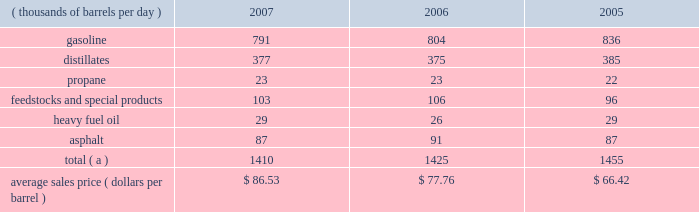Marketing we are a supplier of gasoline and distillates to resellers and consumers within our market area in the midwest , upper great plains , gulf coast and southeastern regions of the united states .
In 2007 , our refined products sales volumes totaled 21.6 billion gallons , or 1.410 mmbpd .
The average sales price of our refined products in aggregate was $ 86.53 per barrel for 2007 .
The table sets forth our refined products sales by product group and our average sales price for each of the last three years .
Refined product sales ( thousands of barrels per day ) 2007 2006 2005 .
Total ( a ) 1410 1425 1455 average sales price ( dollars per barrel ) $ 86.53 $ 77.76 $ 66.42 ( a ) includes matching buy/sell volumes of 24 mbpd and 77 mbpd in 2006 and 2005 .
On april 1 , 2006 , we changed our accounting for matching buy/sell arrangements as a result of a new accounting standard .
This change resulted in lower refined products sales volumes for 2007 and the remainder of 2006 than would have been reported under our previous accounting practices .
See note 2 to the consolidated financial statements .
The wholesale distribution of petroleum products to private brand marketers and to large commercial and industrial consumers and sales in the spot market accounted for 69 percent of our refined products sales volumes in 2007 .
We sold 49 percent of our gasoline volumes and 89 percent of our distillates volumes on a wholesale or spot market basis .
Half of our propane is sold into the home heating market , with the balance being purchased by industrial consumers .
Propylene , cumene , aromatics , aliphatics and sulfur are domestically marketed to customers in the chemical industry .
Base lube oils , maleic anhydride , slack wax , extract and pitch are sold throughout the united states and canada , with pitch products also being exported worldwide .
We market asphalt through owned and leased terminals throughout the midwest , upper great plains , gulf coast and southeastern regions of the united states .
Our customer base includes approximately 750 asphalt-paving contractors , government entities ( states , counties , cities and townships ) and asphalt roofing shingle manufacturers .
We have blended ethanol with gasoline for over 15 years and increased our blending program in 2007 , in part due to renewable fuel mandates .
We blended 41 mbpd of ethanol into gasoline in 2007 and 35 mbpd in both 2006 and 2005 .
The future expansion or contraction of our ethanol blending program will be driven by the economics of the ethanol supply and changes in government regulations .
We sell reformulated gasoline in parts of our marketing territory , primarily chicago , illinois ; louisville , kentucky ; northern kentucky ; milwaukee , wisconsin and hartford , illinois , and we sell low-vapor-pressure gasoline in nine states .
We also sell biodiesel in minnesota , illinois and kentucky .
As of december 31 , 2007 , we supplied petroleum products to about 4400 marathon branded-retail outlets located primarily in ohio , michigan , indiana , kentucky and illinois .
Branded retail outlets are also located in georgia , florida , minnesota , wisconsin , north carolina , tennessee , west virginia , virginia , south carolina , alabama , pennsylvania , and texas .
Sales to marathon-brand jobbers and dealers accounted for 16 percent of our refined product sales volumes in 2007 .
Speedway superamerica llc ( 201cssa 201d ) , our wholly-owned subsidiary , sells gasoline and diesel fuel primarily through retail outlets that we operate .
Sales of refined products through these ssa retail outlets accounted for 15 percent of our refined products sales volumes in 2007 .
As of december 31 , 2007 , ssa had 1636 retail outlets in nine states that sold petroleum products and convenience store merchandise and services , primarily under the brand names 201cspeedway 201d and 201csuperamerica . 201d ssa 2019s revenues from the sale of non-petroleum merchandise totaled $ 2.796 billion in 2007 , compared with $ 2.706 billion in 2006 .
Profit levels from the sale of such merchandise and services tend to be less volatile than profit levels from the retail sale of gasoline and diesel fuel .
Ssa also operates 59 valvoline instant oil change retail outlets located in michigan and northwest ohio .
Pilot travel centers llc ( 201cptc 201d ) , our joint venture with pilot corporation ( 201cpilot 201d ) , is the largest operator of travel centers in the united states with 286 locations in 37 states and canada at december 31 , 2007 .
The travel centers offer diesel fuel , gasoline and a variety of other services , including on-premises brand-name restaurants at many locations .
Pilot and marathon each own a 50 percent interest in ptc. .
What was the decline in matching buy/sell volumes in mbpd between 2006 and 2005? 
Computations: (24 - 77)
Answer: -53.0. 